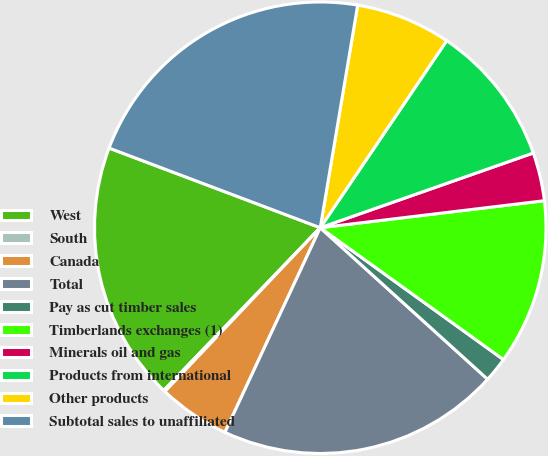Convert chart. <chart><loc_0><loc_0><loc_500><loc_500><pie_chart><fcel>West<fcel>South<fcel>Canada<fcel>Total<fcel>Pay as cut timber sales<fcel>Timberlands exchanges (1)<fcel>Minerals oil and gas<fcel>Products from international<fcel>Other products<fcel>Subtotal sales to unaffiliated<nl><fcel>18.55%<fcel>0.11%<fcel>5.14%<fcel>20.23%<fcel>1.78%<fcel>11.84%<fcel>3.46%<fcel>10.17%<fcel>6.81%<fcel>21.91%<nl></chart> 